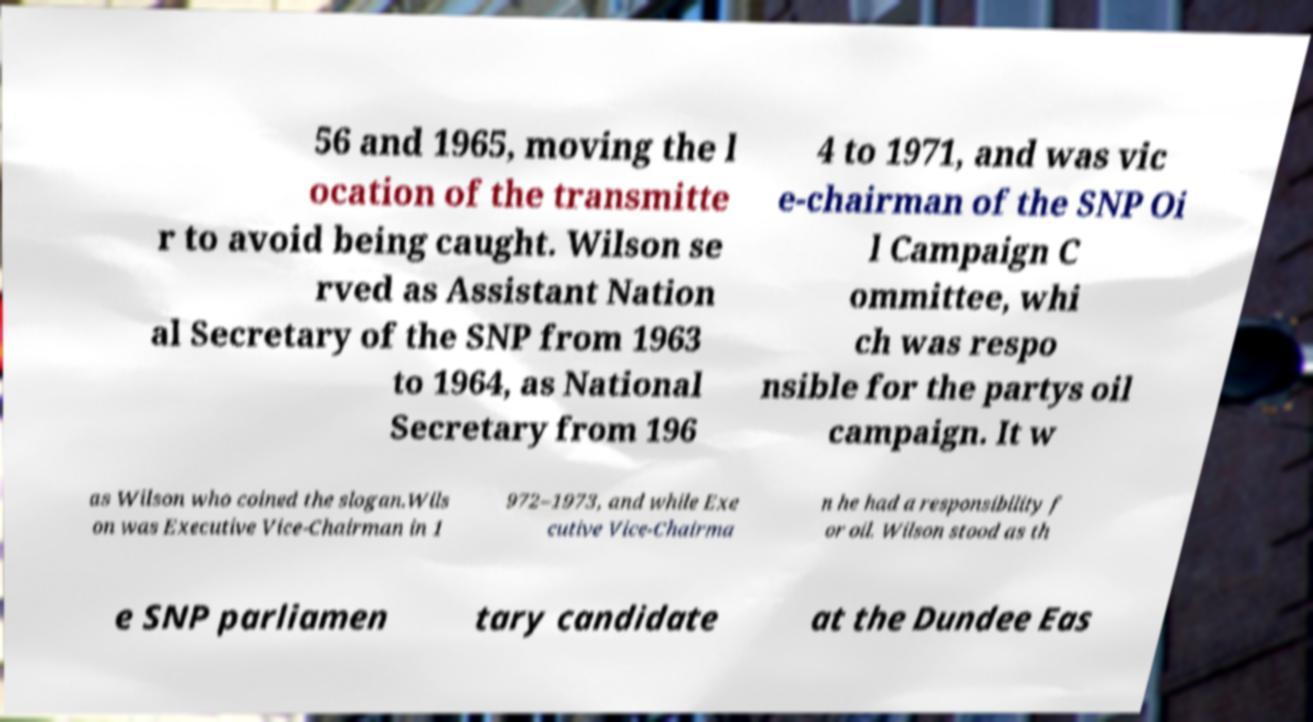For documentation purposes, I need the text within this image transcribed. Could you provide that? 56 and 1965, moving the l ocation of the transmitte r to avoid being caught. Wilson se rved as Assistant Nation al Secretary of the SNP from 1963 to 1964, as National Secretary from 196 4 to 1971, and was vic e-chairman of the SNP Oi l Campaign C ommittee, whi ch was respo nsible for the partys oil campaign. It w as Wilson who coined the slogan.Wils on was Executive Vice-Chairman in 1 972–1973, and while Exe cutive Vice-Chairma n he had a responsibility f or oil. Wilson stood as th e SNP parliamen tary candidate at the Dundee Eas 